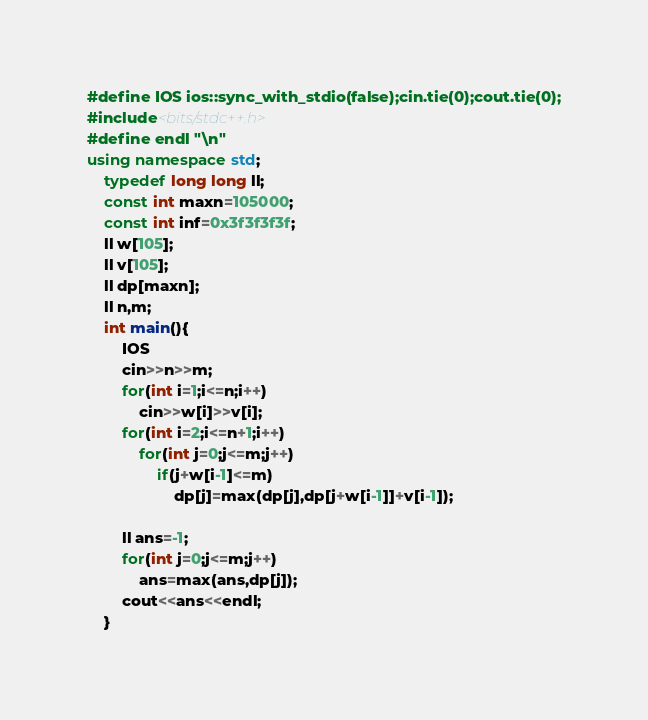<code> <loc_0><loc_0><loc_500><loc_500><_C++_>#define IOS ios::sync_with_stdio(false);cin.tie(0);cout.tie(0);
#include<bits/stdc++.h>  
#define endl "\n"
using namespace std;
	typedef long long ll;
	const int maxn=105000;
	const int inf=0x3f3f3f3f;
	ll w[105];
	ll v[105];
	ll dp[maxn];
	ll n,m;
	int main(){
		IOS
		cin>>n>>m;
		for(int i=1;i<=n;i++)
			cin>>w[i]>>v[i];
		for(int i=2;i<=n+1;i++)
			for(int j=0;j<=m;j++)
				if(j+w[i-1]<=m)
					dp[j]=max(dp[j],dp[j+w[i-1]]+v[i-1]);
			
		ll ans=-1;
		for(int j=0;j<=m;j++)
			ans=max(ans,dp[j]);
		cout<<ans<<endl;
	}</code> 